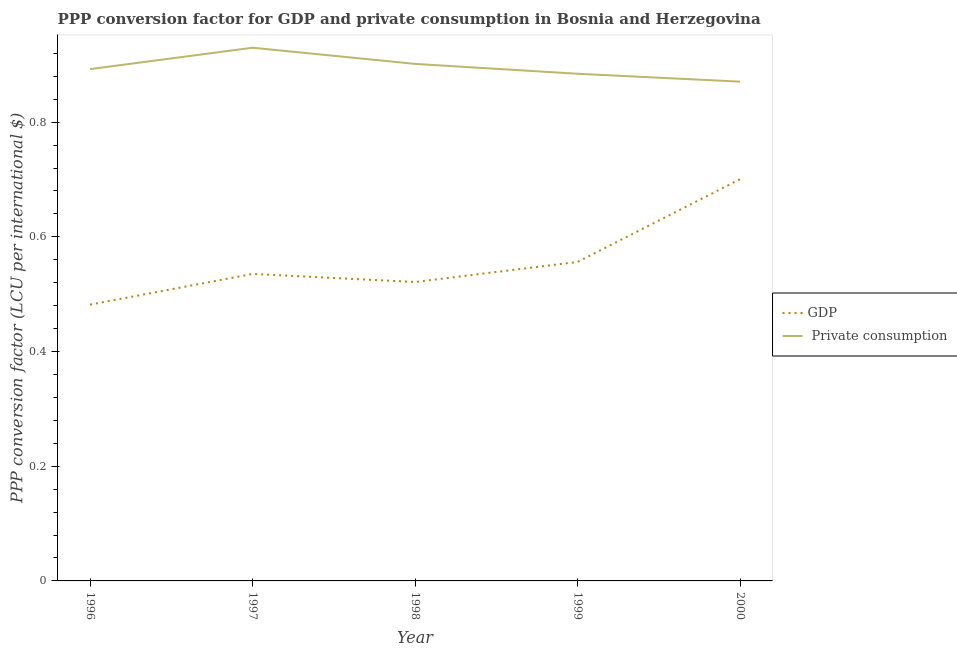How many different coloured lines are there?
Offer a very short reply. 2. What is the ppp conversion factor for private consumption in 1999?
Keep it short and to the point. 0.88. Across all years, what is the maximum ppp conversion factor for gdp?
Provide a succinct answer. 0.7. Across all years, what is the minimum ppp conversion factor for gdp?
Offer a very short reply. 0.48. What is the total ppp conversion factor for private consumption in the graph?
Provide a succinct answer. 4.48. What is the difference between the ppp conversion factor for private consumption in 1996 and that in 2000?
Your answer should be compact. 0.02. What is the difference between the ppp conversion factor for private consumption in 2000 and the ppp conversion factor for gdp in 1996?
Offer a terse response. 0.39. What is the average ppp conversion factor for private consumption per year?
Your answer should be very brief. 0.9. In the year 1996, what is the difference between the ppp conversion factor for private consumption and ppp conversion factor for gdp?
Provide a succinct answer. 0.41. In how many years, is the ppp conversion factor for gdp greater than 0.56 LCU?
Ensure brevity in your answer.  1. What is the ratio of the ppp conversion factor for gdp in 1996 to that in 2000?
Provide a short and direct response. 0.69. Is the ppp conversion factor for gdp in 1999 less than that in 2000?
Give a very brief answer. Yes. What is the difference between the highest and the second highest ppp conversion factor for gdp?
Give a very brief answer. 0.14. What is the difference between the highest and the lowest ppp conversion factor for private consumption?
Offer a terse response. 0.06. Does the ppp conversion factor for gdp monotonically increase over the years?
Provide a succinct answer. No. How many lines are there?
Offer a very short reply. 2. How many years are there in the graph?
Make the answer very short. 5. Does the graph contain grids?
Offer a very short reply. No. How are the legend labels stacked?
Your answer should be compact. Vertical. What is the title of the graph?
Your answer should be very brief. PPP conversion factor for GDP and private consumption in Bosnia and Herzegovina. Does "Working only" appear as one of the legend labels in the graph?
Your answer should be very brief. No. What is the label or title of the X-axis?
Ensure brevity in your answer.  Year. What is the label or title of the Y-axis?
Offer a terse response. PPP conversion factor (LCU per international $). What is the PPP conversion factor (LCU per international $) of GDP in 1996?
Your answer should be compact. 0.48. What is the PPP conversion factor (LCU per international $) in  Private consumption in 1996?
Your response must be concise. 0.89. What is the PPP conversion factor (LCU per international $) in GDP in 1997?
Offer a very short reply. 0.54. What is the PPP conversion factor (LCU per international $) of  Private consumption in 1997?
Offer a very short reply. 0.93. What is the PPP conversion factor (LCU per international $) of GDP in 1998?
Ensure brevity in your answer.  0.52. What is the PPP conversion factor (LCU per international $) of  Private consumption in 1998?
Offer a very short reply. 0.9. What is the PPP conversion factor (LCU per international $) of GDP in 1999?
Make the answer very short. 0.56. What is the PPP conversion factor (LCU per international $) of  Private consumption in 1999?
Keep it short and to the point. 0.88. What is the PPP conversion factor (LCU per international $) of GDP in 2000?
Provide a short and direct response. 0.7. What is the PPP conversion factor (LCU per international $) in  Private consumption in 2000?
Ensure brevity in your answer.  0.87. Across all years, what is the maximum PPP conversion factor (LCU per international $) in GDP?
Provide a succinct answer. 0.7. Across all years, what is the maximum PPP conversion factor (LCU per international $) in  Private consumption?
Your response must be concise. 0.93. Across all years, what is the minimum PPP conversion factor (LCU per international $) in GDP?
Provide a short and direct response. 0.48. Across all years, what is the minimum PPP conversion factor (LCU per international $) of  Private consumption?
Offer a terse response. 0.87. What is the total PPP conversion factor (LCU per international $) of GDP in the graph?
Keep it short and to the point. 2.79. What is the total PPP conversion factor (LCU per international $) of  Private consumption in the graph?
Make the answer very short. 4.48. What is the difference between the PPP conversion factor (LCU per international $) of GDP in 1996 and that in 1997?
Ensure brevity in your answer.  -0.05. What is the difference between the PPP conversion factor (LCU per international $) of  Private consumption in 1996 and that in 1997?
Your answer should be very brief. -0.04. What is the difference between the PPP conversion factor (LCU per international $) in GDP in 1996 and that in 1998?
Your answer should be compact. -0.04. What is the difference between the PPP conversion factor (LCU per international $) in  Private consumption in 1996 and that in 1998?
Your response must be concise. -0.01. What is the difference between the PPP conversion factor (LCU per international $) of GDP in 1996 and that in 1999?
Your answer should be compact. -0.07. What is the difference between the PPP conversion factor (LCU per international $) of  Private consumption in 1996 and that in 1999?
Offer a terse response. 0.01. What is the difference between the PPP conversion factor (LCU per international $) in GDP in 1996 and that in 2000?
Offer a very short reply. -0.22. What is the difference between the PPP conversion factor (LCU per international $) of  Private consumption in 1996 and that in 2000?
Provide a short and direct response. 0.02. What is the difference between the PPP conversion factor (LCU per international $) of GDP in 1997 and that in 1998?
Ensure brevity in your answer.  0.01. What is the difference between the PPP conversion factor (LCU per international $) of  Private consumption in 1997 and that in 1998?
Provide a short and direct response. 0.03. What is the difference between the PPP conversion factor (LCU per international $) in GDP in 1997 and that in 1999?
Your answer should be compact. -0.02. What is the difference between the PPP conversion factor (LCU per international $) in  Private consumption in 1997 and that in 1999?
Offer a terse response. 0.05. What is the difference between the PPP conversion factor (LCU per international $) in GDP in 1997 and that in 2000?
Provide a succinct answer. -0.17. What is the difference between the PPP conversion factor (LCU per international $) of  Private consumption in 1997 and that in 2000?
Ensure brevity in your answer.  0.06. What is the difference between the PPP conversion factor (LCU per international $) in GDP in 1998 and that in 1999?
Offer a very short reply. -0.04. What is the difference between the PPP conversion factor (LCU per international $) of  Private consumption in 1998 and that in 1999?
Give a very brief answer. 0.02. What is the difference between the PPP conversion factor (LCU per international $) in GDP in 1998 and that in 2000?
Give a very brief answer. -0.18. What is the difference between the PPP conversion factor (LCU per international $) in  Private consumption in 1998 and that in 2000?
Your response must be concise. 0.03. What is the difference between the PPP conversion factor (LCU per international $) of GDP in 1999 and that in 2000?
Your response must be concise. -0.14. What is the difference between the PPP conversion factor (LCU per international $) in  Private consumption in 1999 and that in 2000?
Keep it short and to the point. 0.01. What is the difference between the PPP conversion factor (LCU per international $) of GDP in 1996 and the PPP conversion factor (LCU per international $) of  Private consumption in 1997?
Give a very brief answer. -0.45. What is the difference between the PPP conversion factor (LCU per international $) of GDP in 1996 and the PPP conversion factor (LCU per international $) of  Private consumption in 1998?
Give a very brief answer. -0.42. What is the difference between the PPP conversion factor (LCU per international $) in GDP in 1996 and the PPP conversion factor (LCU per international $) in  Private consumption in 1999?
Offer a very short reply. -0.4. What is the difference between the PPP conversion factor (LCU per international $) of GDP in 1996 and the PPP conversion factor (LCU per international $) of  Private consumption in 2000?
Your answer should be very brief. -0.39. What is the difference between the PPP conversion factor (LCU per international $) in GDP in 1997 and the PPP conversion factor (LCU per international $) in  Private consumption in 1998?
Your answer should be very brief. -0.37. What is the difference between the PPP conversion factor (LCU per international $) of GDP in 1997 and the PPP conversion factor (LCU per international $) of  Private consumption in 1999?
Make the answer very short. -0.35. What is the difference between the PPP conversion factor (LCU per international $) in GDP in 1997 and the PPP conversion factor (LCU per international $) in  Private consumption in 2000?
Offer a terse response. -0.34. What is the difference between the PPP conversion factor (LCU per international $) of GDP in 1998 and the PPP conversion factor (LCU per international $) of  Private consumption in 1999?
Ensure brevity in your answer.  -0.36. What is the difference between the PPP conversion factor (LCU per international $) in GDP in 1998 and the PPP conversion factor (LCU per international $) in  Private consumption in 2000?
Give a very brief answer. -0.35. What is the difference between the PPP conversion factor (LCU per international $) of GDP in 1999 and the PPP conversion factor (LCU per international $) of  Private consumption in 2000?
Offer a very short reply. -0.31. What is the average PPP conversion factor (LCU per international $) in GDP per year?
Provide a succinct answer. 0.56. What is the average PPP conversion factor (LCU per international $) of  Private consumption per year?
Your response must be concise. 0.9. In the year 1996, what is the difference between the PPP conversion factor (LCU per international $) in GDP and PPP conversion factor (LCU per international $) in  Private consumption?
Make the answer very short. -0.41. In the year 1997, what is the difference between the PPP conversion factor (LCU per international $) in GDP and PPP conversion factor (LCU per international $) in  Private consumption?
Offer a very short reply. -0.39. In the year 1998, what is the difference between the PPP conversion factor (LCU per international $) in GDP and PPP conversion factor (LCU per international $) in  Private consumption?
Offer a very short reply. -0.38. In the year 1999, what is the difference between the PPP conversion factor (LCU per international $) of GDP and PPP conversion factor (LCU per international $) of  Private consumption?
Your response must be concise. -0.33. In the year 2000, what is the difference between the PPP conversion factor (LCU per international $) of GDP and PPP conversion factor (LCU per international $) of  Private consumption?
Offer a terse response. -0.17. What is the ratio of the PPP conversion factor (LCU per international $) in  Private consumption in 1996 to that in 1997?
Provide a short and direct response. 0.96. What is the ratio of the PPP conversion factor (LCU per international $) in GDP in 1996 to that in 1998?
Give a very brief answer. 0.92. What is the ratio of the PPP conversion factor (LCU per international $) in GDP in 1996 to that in 1999?
Your response must be concise. 0.87. What is the ratio of the PPP conversion factor (LCU per international $) of  Private consumption in 1996 to that in 1999?
Offer a very short reply. 1.01. What is the ratio of the PPP conversion factor (LCU per international $) in GDP in 1996 to that in 2000?
Provide a succinct answer. 0.69. What is the ratio of the PPP conversion factor (LCU per international $) in  Private consumption in 1996 to that in 2000?
Your response must be concise. 1.03. What is the ratio of the PPP conversion factor (LCU per international $) of GDP in 1997 to that in 1998?
Your answer should be compact. 1.03. What is the ratio of the PPP conversion factor (LCU per international $) of  Private consumption in 1997 to that in 1998?
Provide a succinct answer. 1.03. What is the ratio of the PPP conversion factor (LCU per international $) of GDP in 1997 to that in 1999?
Offer a terse response. 0.96. What is the ratio of the PPP conversion factor (LCU per international $) of  Private consumption in 1997 to that in 1999?
Give a very brief answer. 1.05. What is the ratio of the PPP conversion factor (LCU per international $) of GDP in 1997 to that in 2000?
Your response must be concise. 0.76. What is the ratio of the PPP conversion factor (LCU per international $) of  Private consumption in 1997 to that in 2000?
Provide a short and direct response. 1.07. What is the ratio of the PPP conversion factor (LCU per international $) of GDP in 1998 to that in 1999?
Provide a succinct answer. 0.94. What is the ratio of the PPP conversion factor (LCU per international $) in  Private consumption in 1998 to that in 1999?
Your answer should be very brief. 1.02. What is the ratio of the PPP conversion factor (LCU per international $) of GDP in 1998 to that in 2000?
Offer a very short reply. 0.74. What is the ratio of the PPP conversion factor (LCU per international $) in  Private consumption in 1998 to that in 2000?
Your answer should be very brief. 1.04. What is the ratio of the PPP conversion factor (LCU per international $) of GDP in 1999 to that in 2000?
Your answer should be very brief. 0.79. What is the ratio of the PPP conversion factor (LCU per international $) in  Private consumption in 1999 to that in 2000?
Your answer should be compact. 1.02. What is the difference between the highest and the second highest PPP conversion factor (LCU per international $) of GDP?
Ensure brevity in your answer.  0.14. What is the difference between the highest and the second highest PPP conversion factor (LCU per international $) in  Private consumption?
Your answer should be compact. 0.03. What is the difference between the highest and the lowest PPP conversion factor (LCU per international $) of GDP?
Your answer should be compact. 0.22. What is the difference between the highest and the lowest PPP conversion factor (LCU per international $) of  Private consumption?
Make the answer very short. 0.06. 